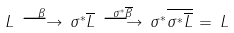Convert formula to latex. <formula><loc_0><loc_0><loc_500><loc_500>L \, \stackrel { \beta } { \longrightarrow } \, \sigma ^ { * } \overline { L } \, \stackrel { \sigma ^ { * } \overline { \beta } } { \longrightarrow } \, \sigma ^ { * } \overline { \sigma ^ { * } \overline { L } } \, = \, L</formula> 